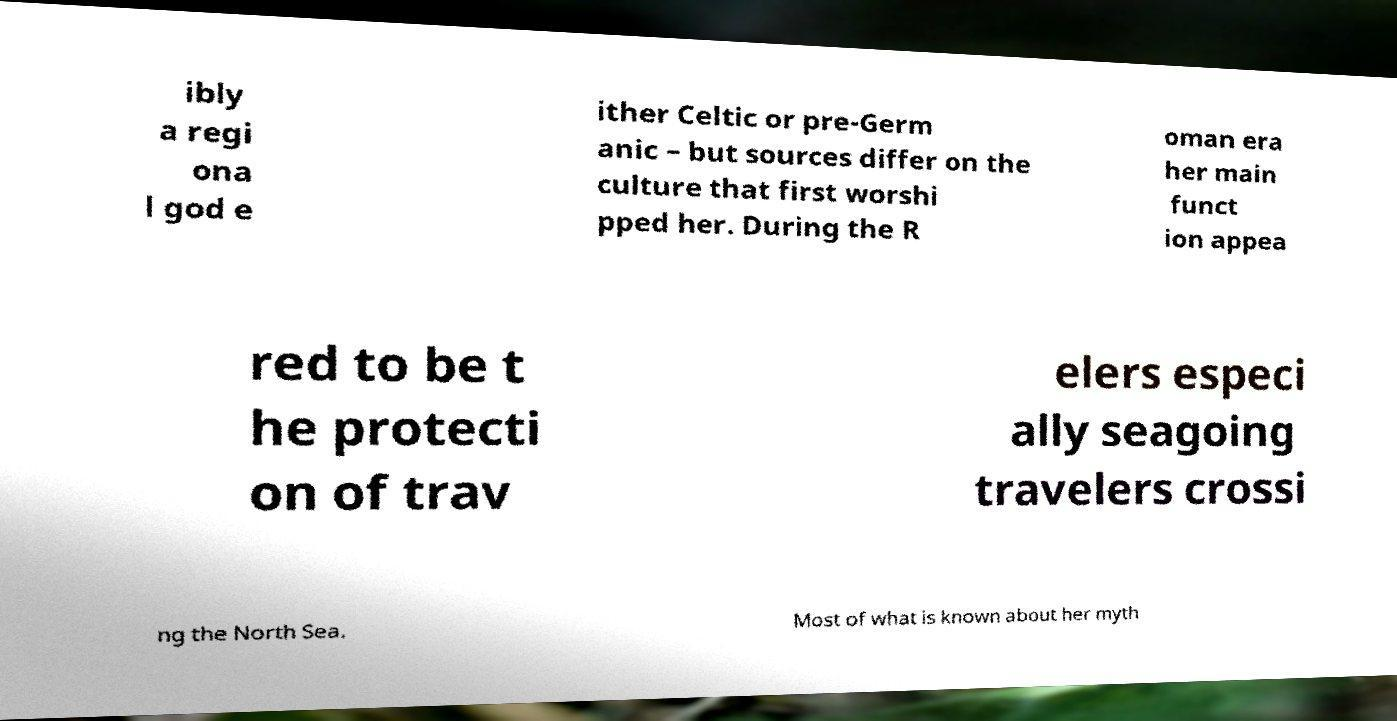Can you accurately transcribe the text from the provided image for me? ibly a regi ona l god e ither Celtic or pre-Germ anic – but sources differ on the culture that first worshi pped her. During the R oman era her main funct ion appea red to be t he protecti on of trav elers especi ally seagoing travelers crossi ng the North Sea. Most of what is known about her myth 